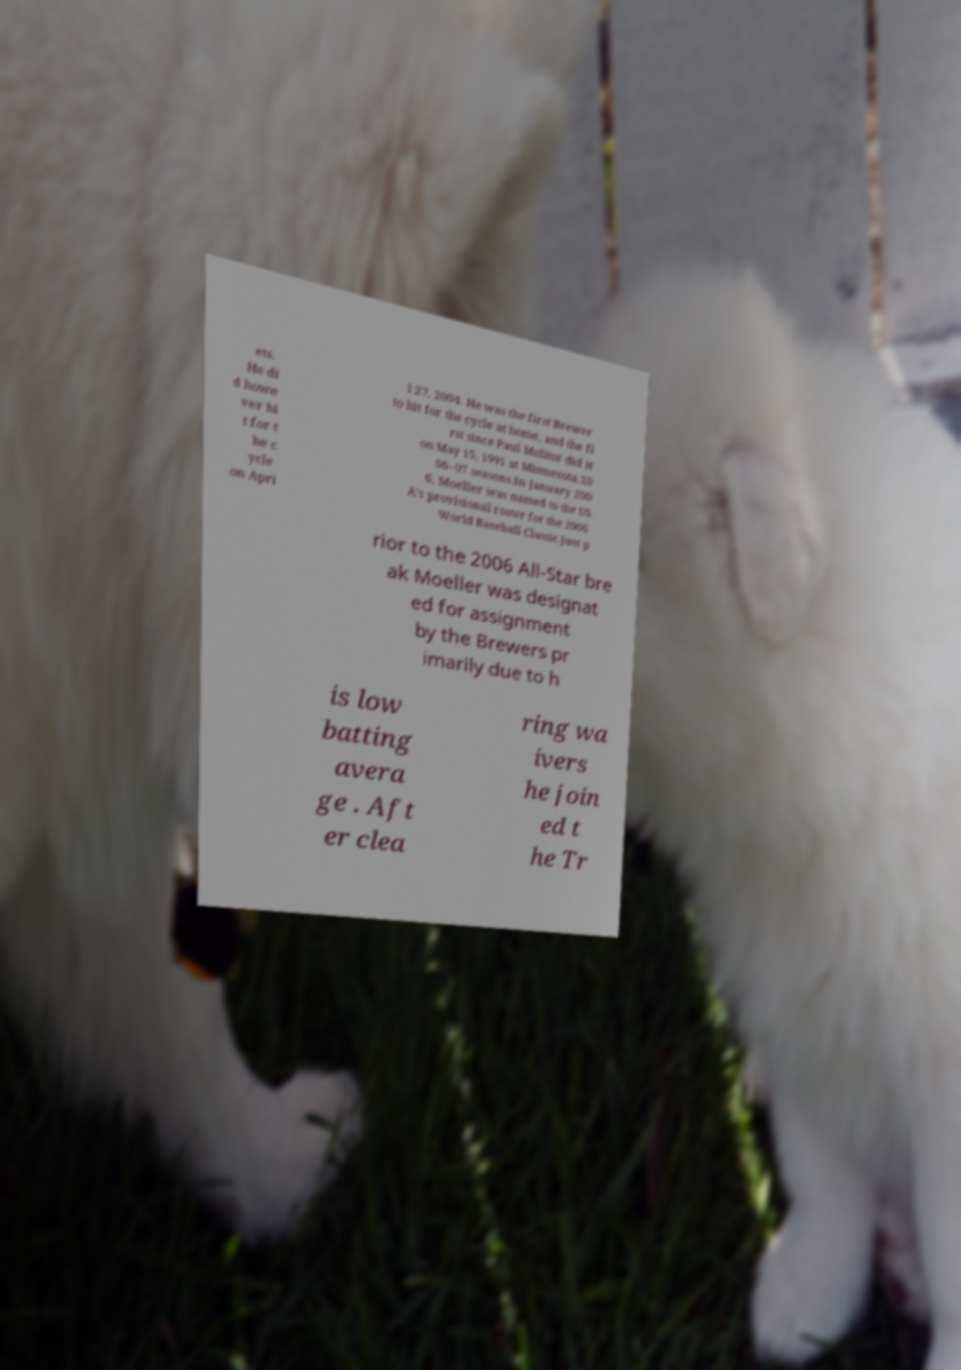For documentation purposes, I need the text within this image transcribed. Could you provide that? ets. He di d howe ver hi t for t he c ycle on Apri l 27, 2004. He was the first Brewer to hit for the cycle at home, and the fi rst since Paul Molitor did it on May 15, 1991 at Minnesota.20 06–07 seasons.In January 200 6, Moeller was named to the US A's provisional roster for the 2006 World Baseball Classic.Just p rior to the 2006 All-Star bre ak Moeller was designat ed for assignment by the Brewers pr imarily due to h is low batting avera ge . Aft er clea ring wa ivers he join ed t he Tr 